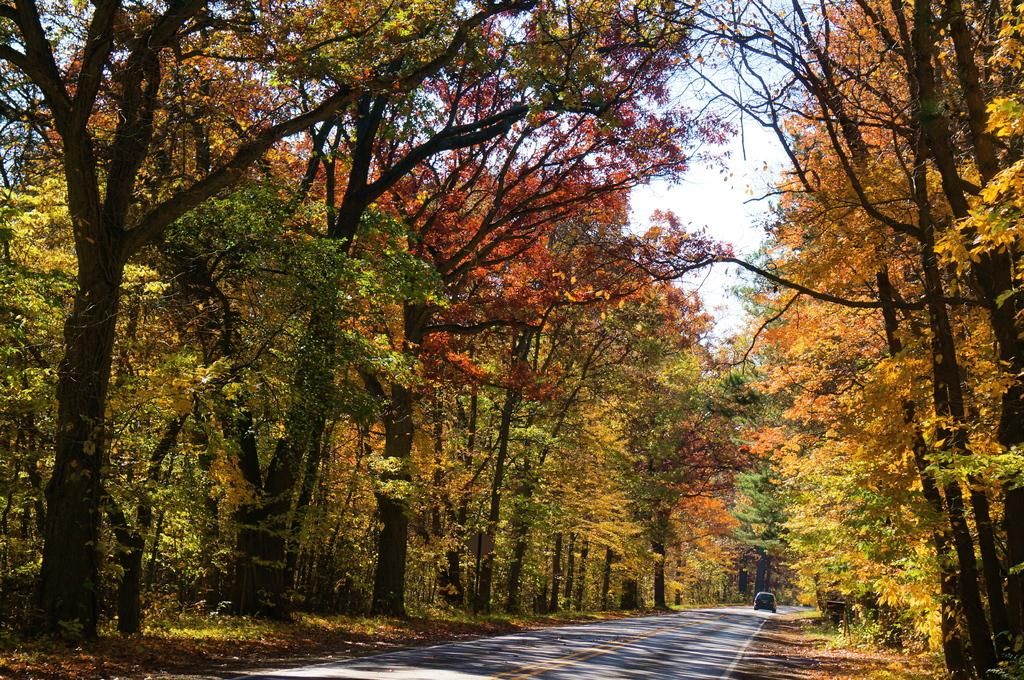What is in the foreground of the image? There is a road in the foreground of the image. What is on the road? There is a vehicle on the road. What type of vegetation is present on either side of the road? There are trees on either side of the road. What can be seen at the top of the image? The sky is visible at the top of the image. What type of jam is being spread on the zebra in the image? There is no zebra or jam present in the image. 